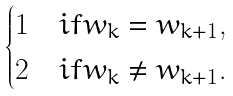<formula> <loc_0><loc_0><loc_500><loc_500>\begin{cases} 1 & i f w _ { k } = w _ { k + 1 } , \\ 2 & i f w _ { k } \neq w _ { k + 1 } . \end{cases}</formula> 